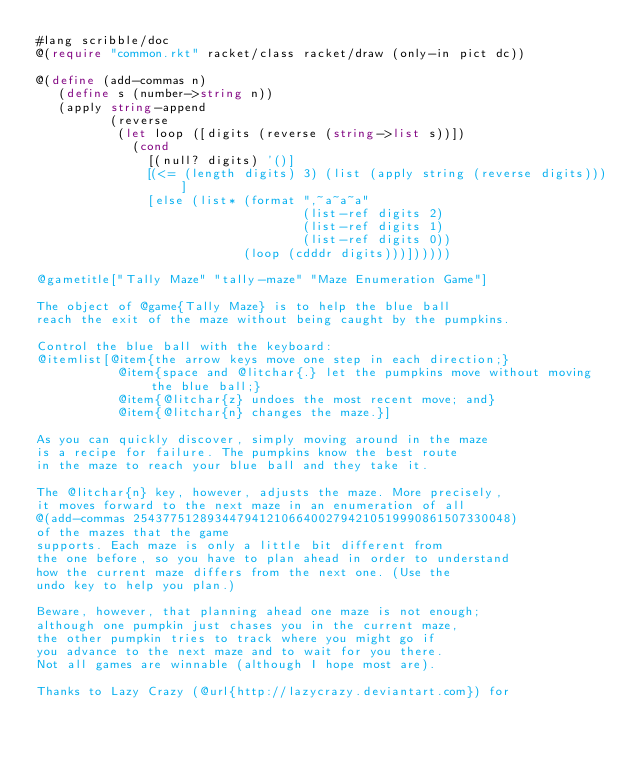<code> <loc_0><loc_0><loc_500><loc_500><_Racket_>#lang scribble/doc
@(require "common.rkt" racket/class racket/draw (only-in pict dc))

@(define (add-commas n)
   (define s (number->string n))
   (apply string-append
          (reverse
           (let loop ([digits (reverse (string->list s))])
             (cond
               [(null? digits) '()]
               [(<= (length digits) 3) (list (apply string (reverse digits)))]
               [else (list* (format ",~a~a~a"
                                    (list-ref digits 2)
                                    (list-ref digits 1)
                                    (list-ref digits 0))
                            (loop (cdddr digits)))])))))

@gametitle["Tally Maze" "tally-maze" "Maze Enumeration Game"]

The object of @game{Tally Maze} is to help the blue ball 
reach the exit of the maze without being caught by the pumpkins.

Control the blue ball with the keyboard: 
@itemlist[@item{the arrow keys move one step in each direction;}
           @item{space and @litchar{.} let the pumpkins move without moving the blue ball;}
           @item{@litchar{z} undoes the most recent move; and}
           @item{@litchar{n} changes the maze.}]

As you can quickly discover, simply moving around in the maze
is a recipe for failure. The pumpkins know the best route 
in the maze to reach your blue ball and they take it.

The @litchar{n} key, however, adjusts the maze. More precisely,
it moves forward to the next maze in an enumeration of all 
@(add-commas 254377512893447941210664002794210519990861507330048)
of the mazes that the game
supports. Each maze is only a little bit different from
the one before, so you have to plan ahead in order to understand
how the current maze differs from the next one. (Use the
undo key to help you plan.)

Beware, however, that planning ahead one maze is not enough;
although one pumpkin just chases you in the current maze,
the other pumpkin tries to track where you might go if
you advance to the next maze and to wait for you there.
Not all games are winnable (although I hope most are).

Thanks to Lazy Crazy (@url{http://lazycrazy.deviantart.com}) for</code> 